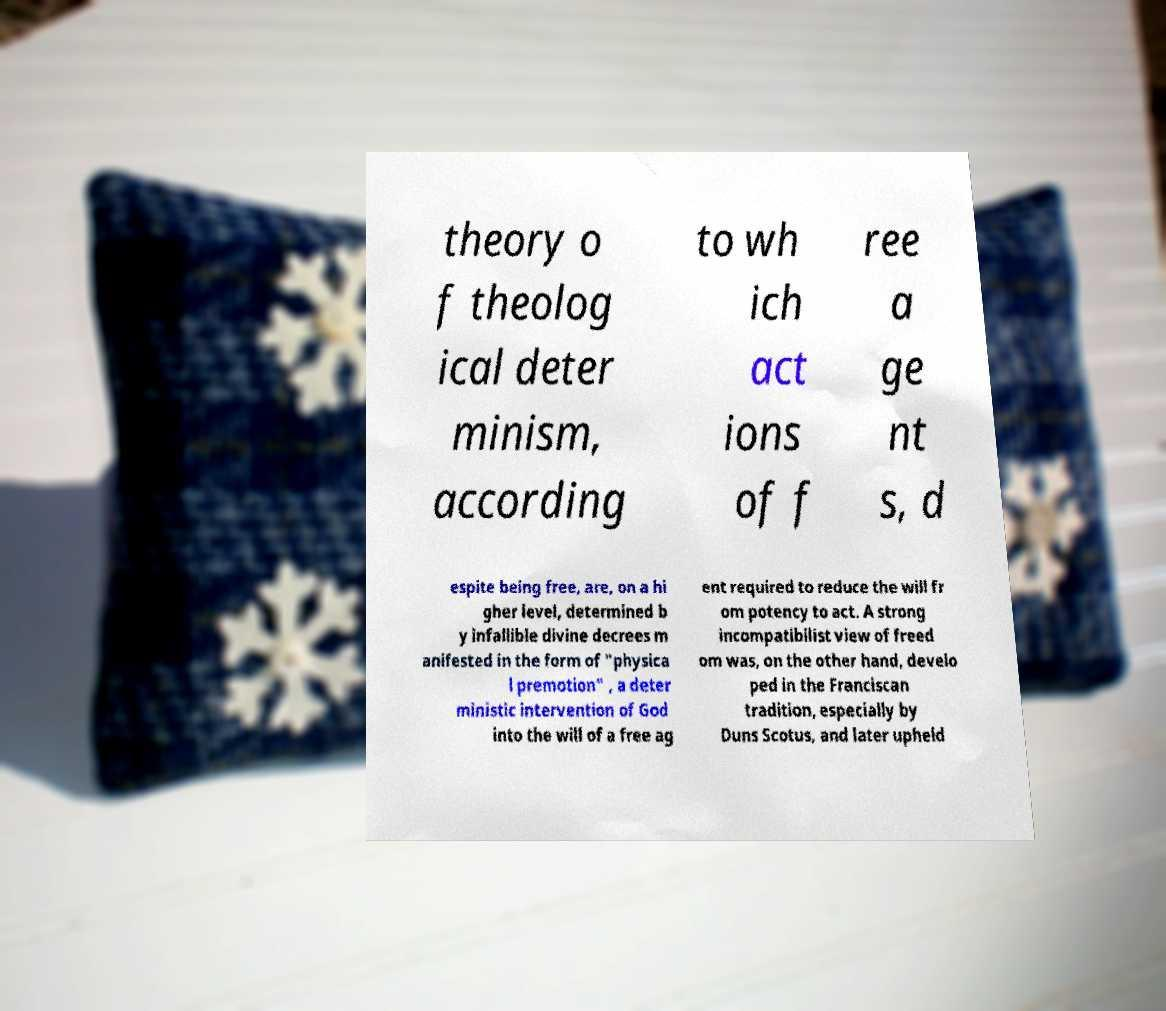For documentation purposes, I need the text within this image transcribed. Could you provide that? theory o f theolog ical deter minism, according to wh ich act ions of f ree a ge nt s, d espite being free, are, on a hi gher level, determined b y infallible divine decrees m anifested in the form of "physica l premotion" , a deter ministic intervention of God into the will of a free ag ent required to reduce the will fr om potency to act. A strong incompatibilist view of freed om was, on the other hand, develo ped in the Franciscan tradition, especially by Duns Scotus, and later upheld 